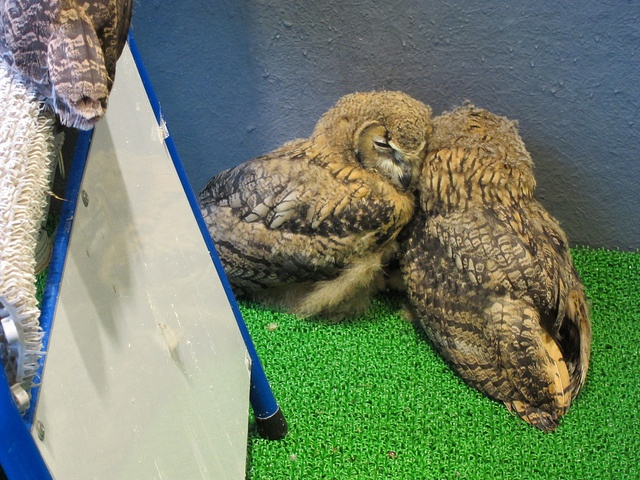Describe the objects in this image and their specific colors. I can see bird in darkgray, tan, gray, black, and olive tones, bird in darkgray, tan, black, gray, and olive tones, and bird in darkgray, gray, and black tones in this image. 